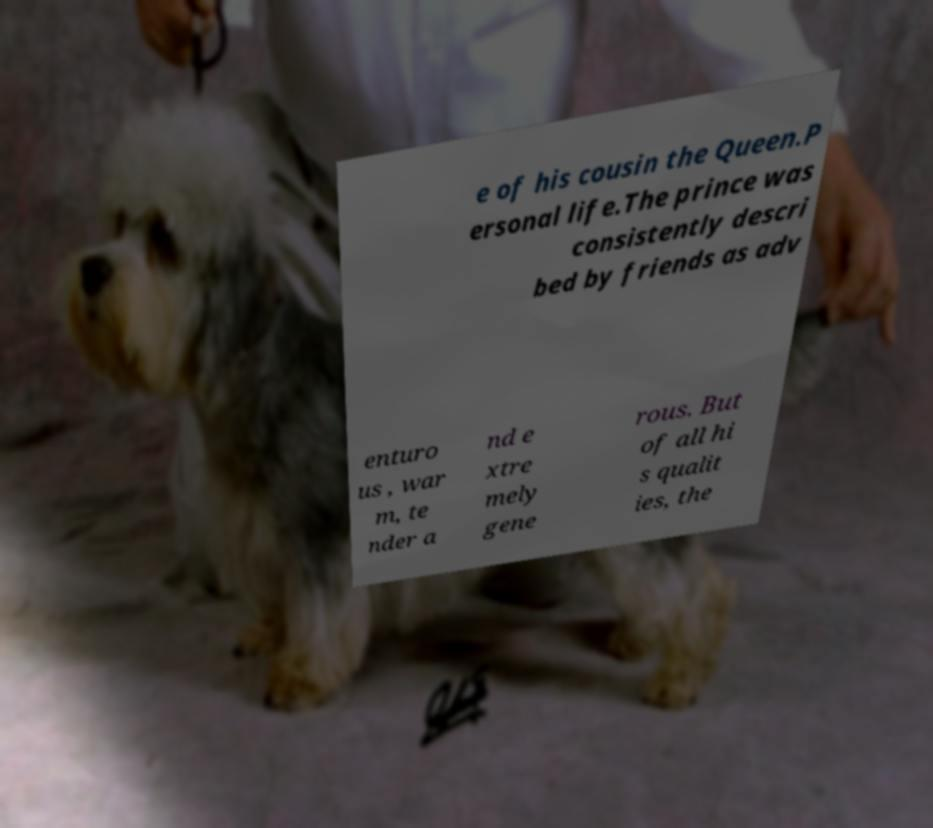There's text embedded in this image that I need extracted. Can you transcribe it verbatim? e of his cousin the Queen.P ersonal life.The prince was consistently descri bed by friends as adv enturo us , war m, te nder a nd e xtre mely gene rous. But of all hi s qualit ies, the 